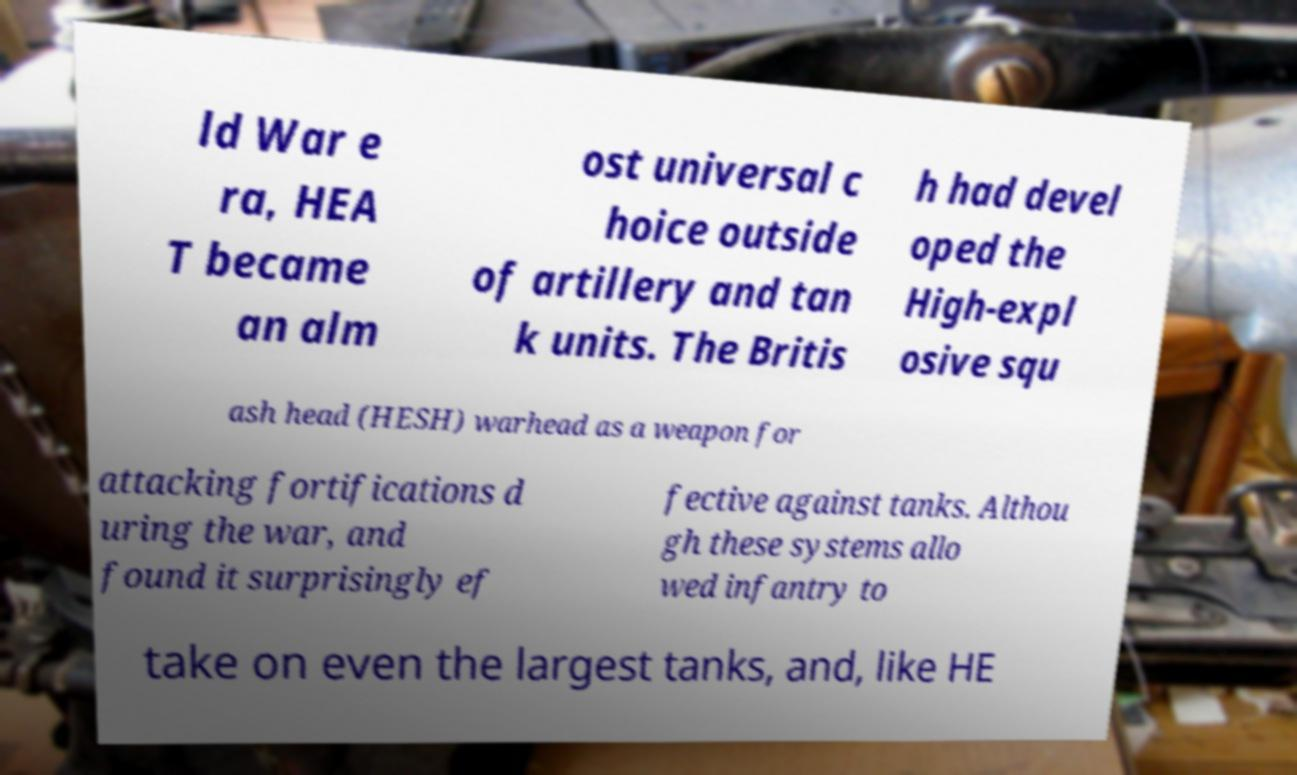Please read and relay the text visible in this image. What does it say? ld War e ra, HEA T became an alm ost universal c hoice outside of artillery and tan k units. The Britis h had devel oped the High-expl osive squ ash head (HESH) warhead as a weapon for attacking fortifications d uring the war, and found it surprisingly ef fective against tanks. Althou gh these systems allo wed infantry to take on even the largest tanks, and, like HE 